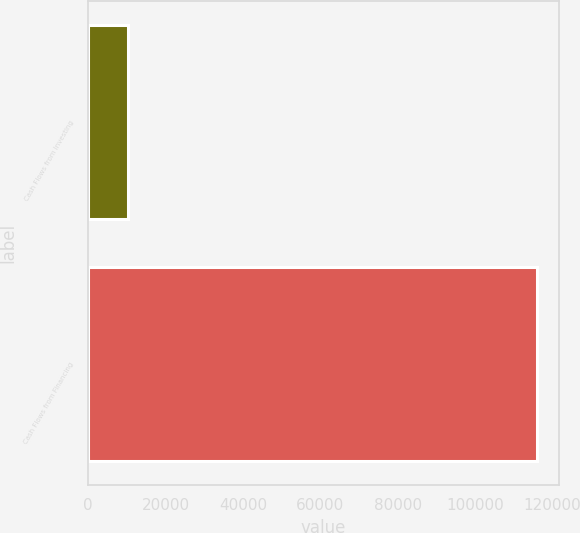Convert chart to OTSL. <chart><loc_0><loc_0><loc_500><loc_500><bar_chart><fcel>Cash Flows from Investing<fcel>Cash Flows from Financing<nl><fcel>10207<fcel>115922<nl></chart> 